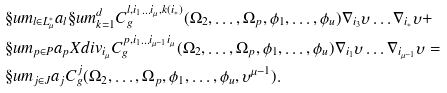Convert formula to latex. <formula><loc_0><loc_0><loc_500><loc_500>& \S u m _ { l \in L ^ { * } _ { \mu } } a _ { l } \S u m _ { k = 1 } ^ { d } C ^ { l , i _ { 1 } \dots i _ { \mu } , k ( i _ { * } ) } _ { g } ( \Omega _ { 2 } , \dots , \Omega _ { p } , \phi _ { 1 } , \dots , \phi _ { u } ) \nabla _ { i _ { 3 } } \upsilon \dots \nabla _ { i _ { * } } \upsilon + \\ & \S u m _ { p \in P } a _ { p } X d i v _ { i _ { \mu } } C ^ { p , i _ { 1 } \dots i _ { \mu - 1 } i _ { \mu } } _ { g } ( \Omega _ { 2 } , \dots , \Omega _ { p } , \phi _ { 1 } , \dots , \phi _ { u } ) \nabla _ { i _ { 1 } } \upsilon \dots \nabla _ { i _ { \mu - 1 } } \upsilon = \\ & \S u m _ { j \in J } a _ { j } C ^ { j } _ { g } ( \Omega _ { 2 } , \dots , \Omega _ { p } , \phi _ { 1 } , \dots , \phi _ { u } , \upsilon ^ { \mu - 1 } ) .</formula> 